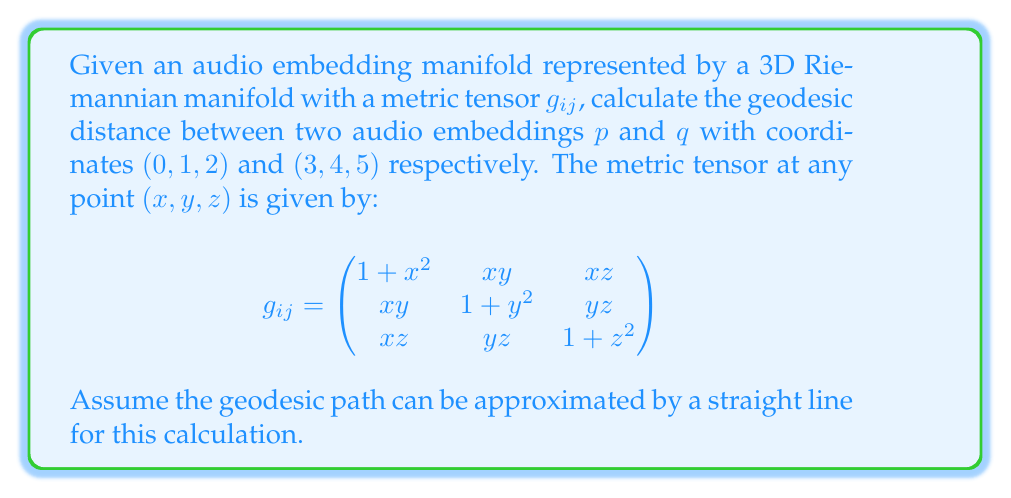Provide a solution to this math problem. To calculate the approximate geodesic distance between two points on a Riemannian manifold, we can use the following steps:

1. Calculate the coordinate differences:
   $\Delta x = 3 - 0 = 3$
   $\Delta y = 4 - 1 = 3$
   $\Delta z = 5 - 2 = 3$

2. Find the midpoint of the path:
   $x_m = (0 + 3)/2 = 1.5$
   $y_m = (1 + 4)/2 = 2.5$
   $z_m = (2 + 5)/2 = 3.5$

3. Evaluate the metric tensor at the midpoint:
   $$g_{ij} = \begin{pmatrix}
   1 + (1.5)^2 & (1.5)(2.5) & (1.5)(3.5) \\
   (1.5)(2.5) & 1 + (2.5)^2 & (2.5)(3.5) \\
   (1.5)(3.5) & (2.5)(3.5) & 1 + (3.5)^2
   \end{pmatrix}$$

   $$g_{ij} = \begin{pmatrix}
   3.25 & 3.75 & 5.25 \\
   3.75 & 7.25 & 8.75 \\
   5.25 & 8.75 & 13.25
   \end{pmatrix}$$

4. Calculate the squared distance using the metric tensor:
   $$d^2 = \sum_{i,j=1}^3 g_{ij} \Delta x_i \Delta x_j$$

   $$d^2 = 3.25(3^2) + 7.25(3^2) + 13.25(3^2) + 2(3.75 + 5.25 + 8.75)(3)(3)$$

   $$d^2 = 29.25 + 65.25 + 119.25 + 106.5 = 320.25$$

5. Take the square root to get the approximate geodesic distance:
   $$d = \sqrt{320.25} = 17.896$$
Answer: $17.896$ 